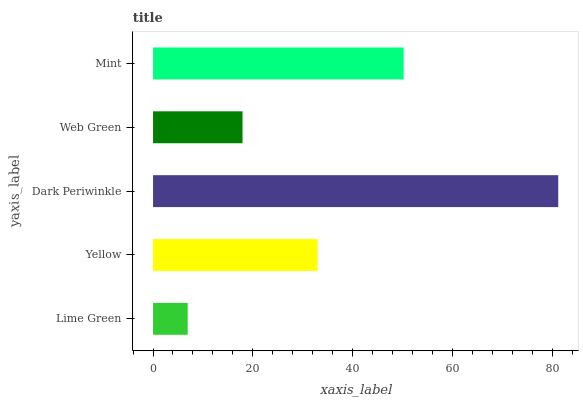Is Lime Green the minimum?
Answer yes or no. Yes. Is Dark Periwinkle the maximum?
Answer yes or no. Yes. Is Yellow the minimum?
Answer yes or no. No. Is Yellow the maximum?
Answer yes or no. No. Is Yellow greater than Lime Green?
Answer yes or no. Yes. Is Lime Green less than Yellow?
Answer yes or no. Yes. Is Lime Green greater than Yellow?
Answer yes or no. No. Is Yellow less than Lime Green?
Answer yes or no. No. Is Yellow the high median?
Answer yes or no. Yes. Is Yellow the low median?
Answer yes or no. Yes. Is Web Green the high median?
Answer yes or no. No. Is Mint the low median?
Answer yes or no. No. 